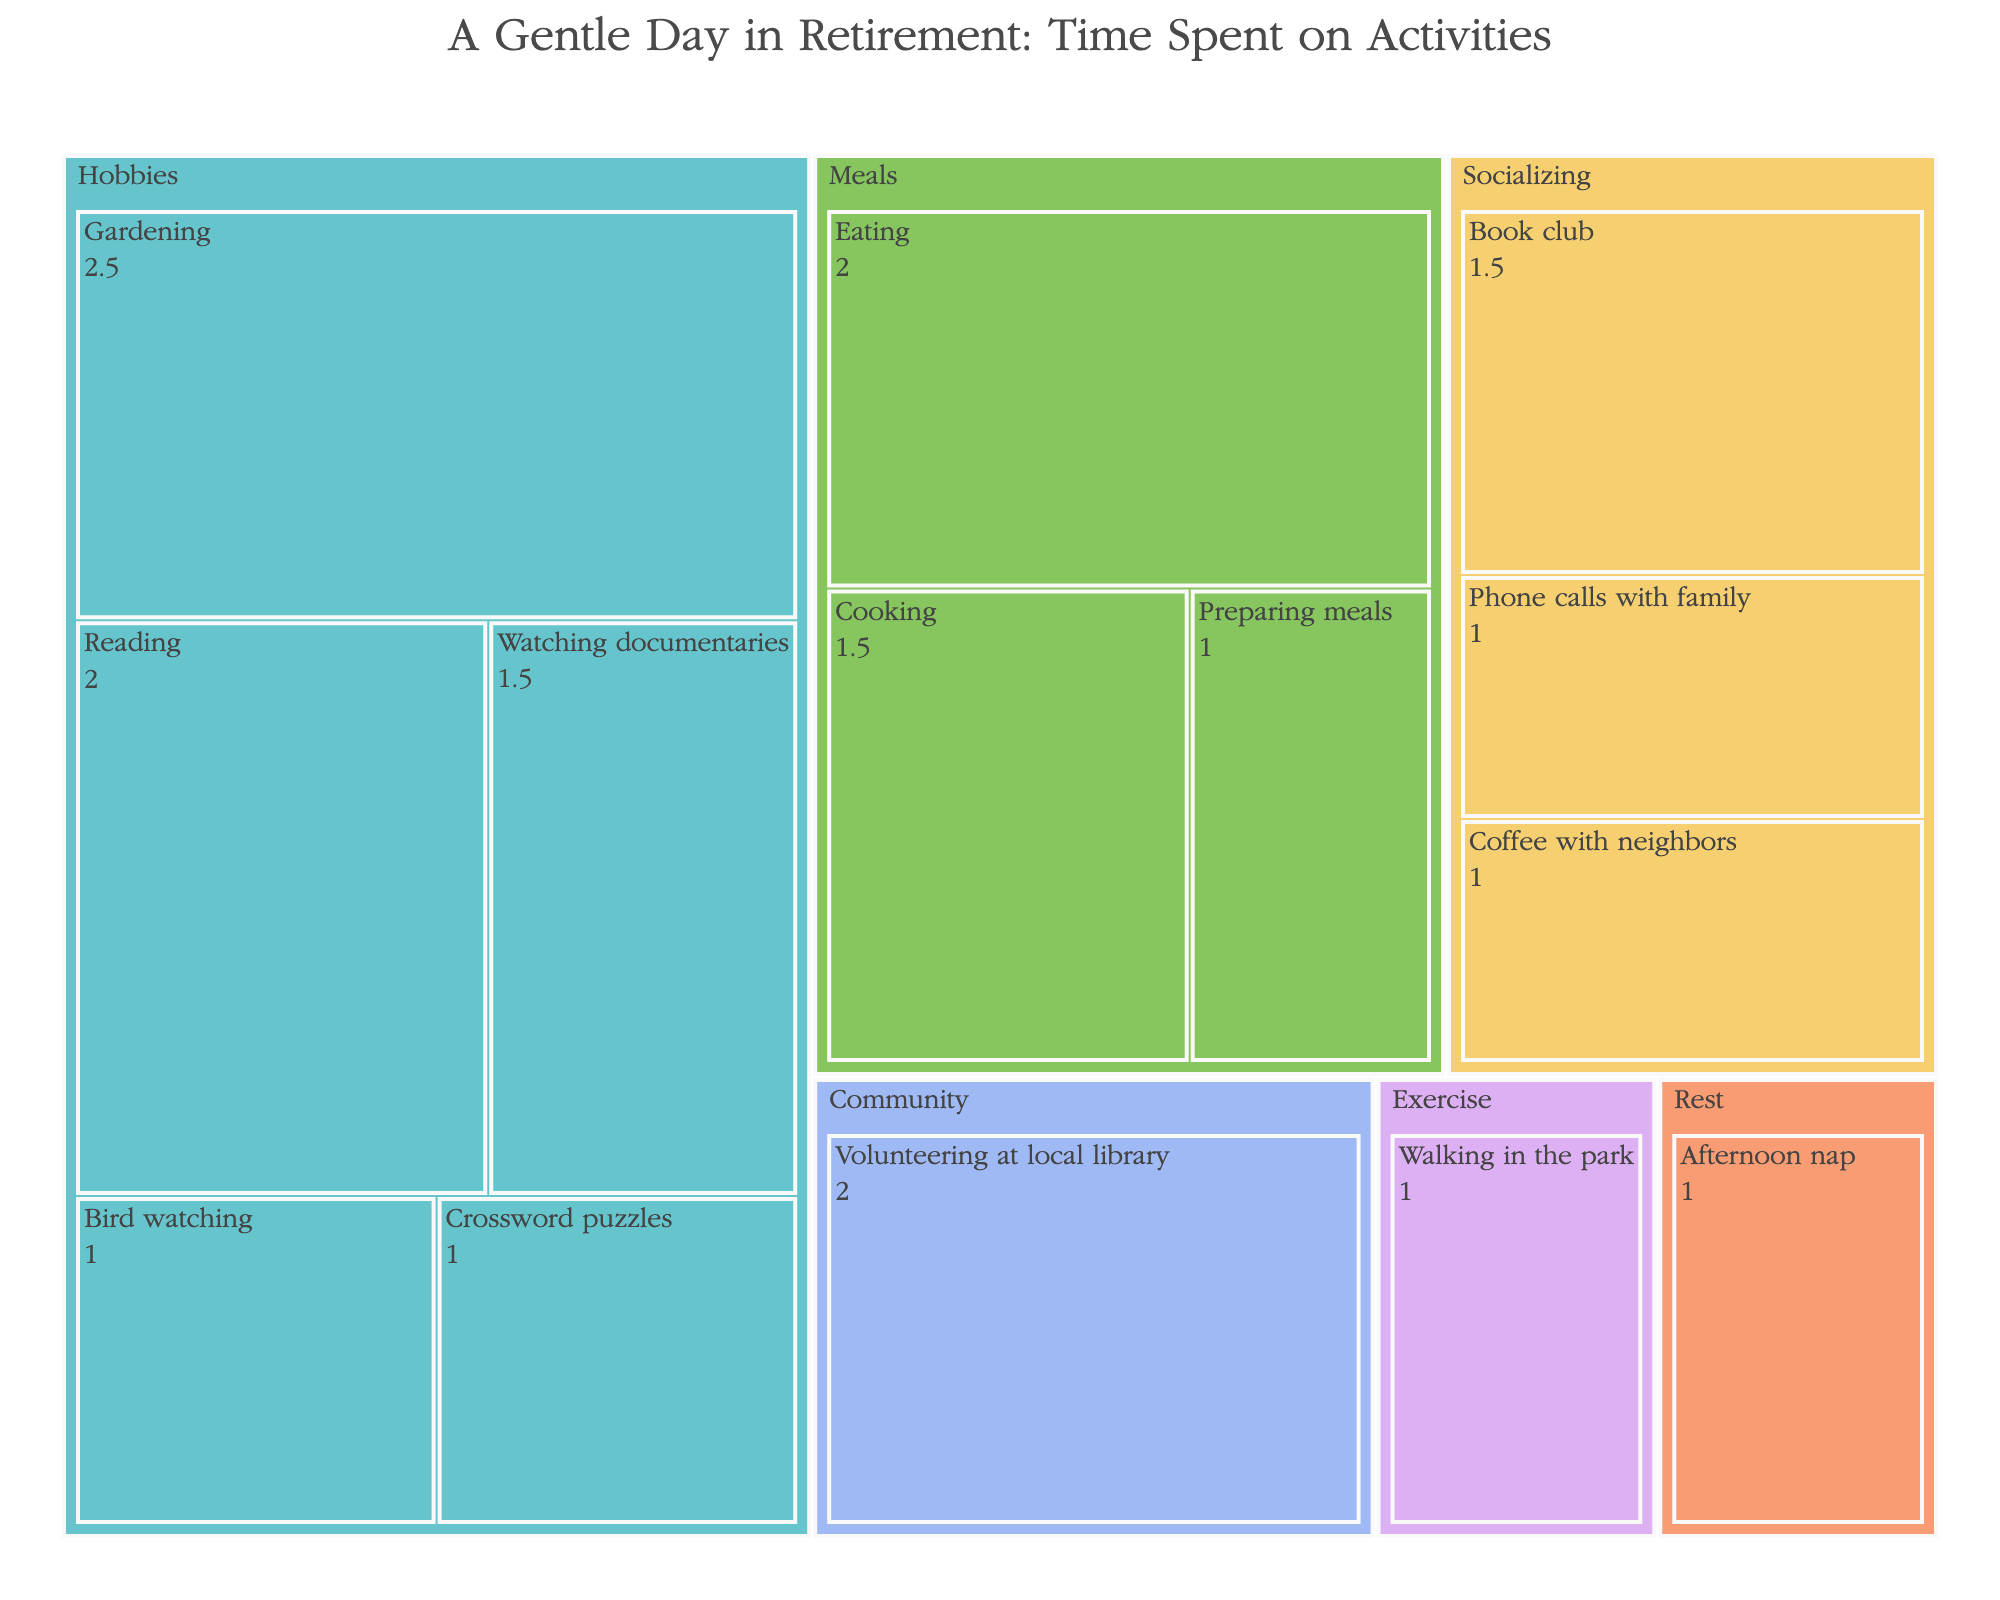How many hours per week are spent on hobbies? To determine the total hours spent on hobbies, sum the hours for gardening, reading, watching documentaries, crossword puzzles, and bird watching (2.5 + 2 + 1.5 + 1 + 1).
Answer: 8 Which activity under the 'Socializing' category takes up the most time? Compare the hours of all activities in the 'Socializing' category: Coffee with neighbors (1 hour), Book club (1.5 hours), and Phone calls with family (1 hour). The Book club has the highest value.
Answer: Book club How many activities are categorized under 'Meals'? Count the number of activities in the 'Meals' category: Cooking, Eating, Preparing meals.
Answer: 3 Which category takes the most time overall? Sum the hours for each category and compare. Hobbies: 8, Meals: 4.5, Socializing: 3.5, Rest: 1, Exercise: 1, Community: 2. The Hobbies category has the highest sum.
Answer: Hobbies How much time in total is spent on Meals and Socializing combined? Sum the hours from the 'Meals' and 'Socializing' categories. Meals (4.5) + Socializing (3.5) = 8.
Answer: 8 Which is shorter, time spent on exercising or time spent on resting? Compare hours for Exercise (Walking in the park, 1 hour) and Rest (Afternoon nap, 1 hour). Both are equal.
Answer: Equal What is the activity with the least amount of time spent on it in the Hobbies category? Compare the hours for all activities in the Hobbies category: Gardening (2.5), Reading (2), Watching documentaries (1.5), Crossword puzzles (1), Bird watching (1). The least time is spent on Crossword puzzles and Bird watching.
Answer: Crossword puzzles, Bird watching How many hours in total are spent on community activities? Sum the hours from the 'Community' category: Volunteering at local library (2 hours).
Answer: 2 What is the difference in time spent between the longest and shortest activity in the Meals category? Identify the longest (Eating, 2 hours) and shortest (Preparing meals, 1 hour) activities. The difference is 2 - 1 = 1.
Answer: 1 How many activities are there in total in the figure? Count the total number of distinct activities listed: Gardening, Reading, Cooking, Eating, Coffee with neighbors, Book club, Afternoon nap, Watching documentaries, Walking in the park, Preparing meals, Crossword puzzles, Phone calls with family, Bird watching, Volunteering at local library.
Answer: 14 